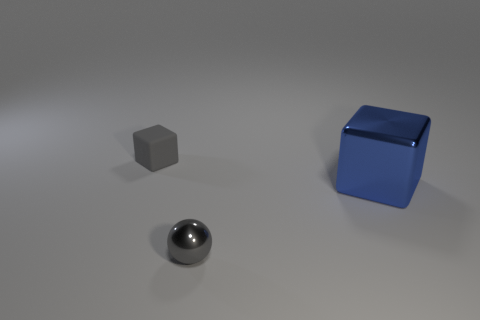There is a cube that is behind the metallic thing that is behind the tiny gray object that is to the right of the small gray matte block; what is it made of?
Keep it short and to the point. Rubber. What is the material of the object that is in front of the big blue shiny cube?
Keep it short and to the point. Metal. Is there another gray thing that has the same size as the gray matte object?
Keep it short and to the point. Yes. There is a cube that is on the left side of the gray metal ball; does it have the same color as the metallic sphere?
Your answer should be compact. Yes. What number of red objects are either metal balls or large metallic blocks?
Keep it short and to the point. 0. What number of tiny objects are the same color as the small metallic ball?
Provide a short and direct response. 1. Does the blue cube have the same material as the small gray block?
Offer a very short reply. No. How many big blocks are right of the metal thing to the right of the tiny metal ball?
Keep it short and to the point. 0. Is the size of the gray block the same as the gray shiny sphere?
Give a very brief answer. Yes. What number of tiny gray balls are the same material as the big blue block?
Offer a very short reply. 1. 